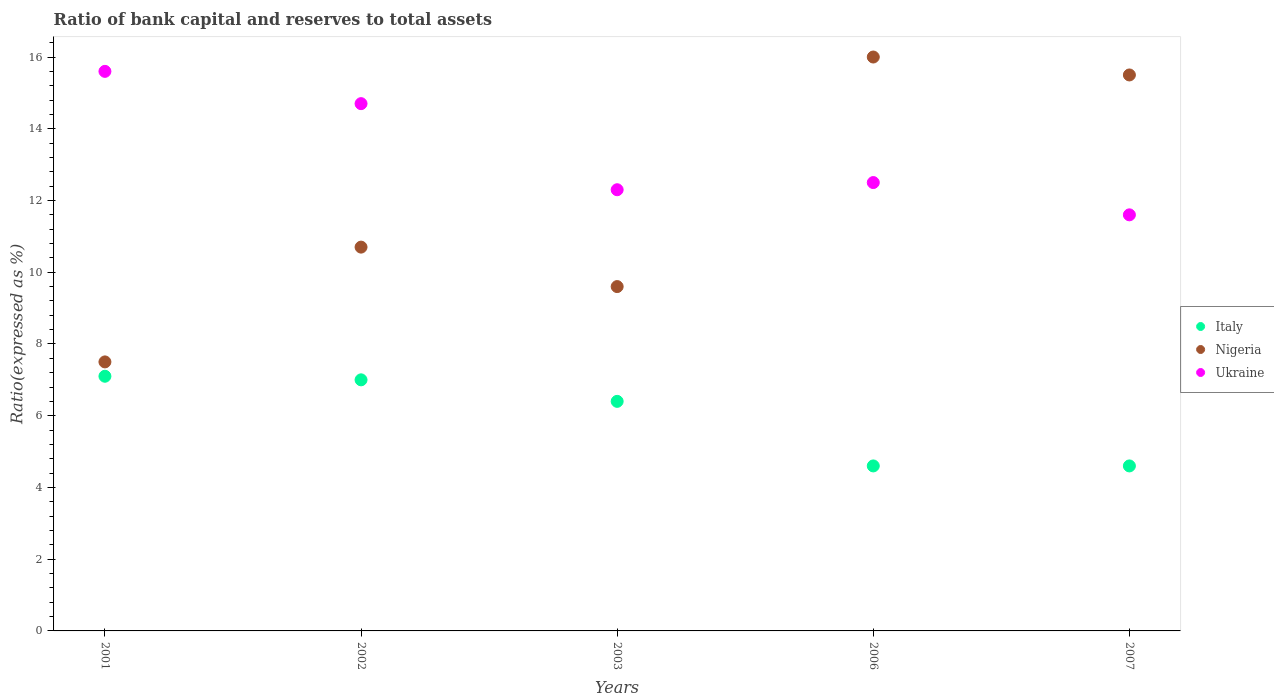How many different coloured dotlines are there?
Ensure brevity in your answer.  3. Across all years, what is the maximum ratio of bank capital and reserves to total assets in Italy?
Your response must be concise. 7.1. What is the total ratio of bank capital and reserves to total assets in Nigeria in the graph?
Your answer should be compact. 59.3. What is the difference between the ratio of bank capital and reserves to total assets in Ukraine in 2002 and that in 2007?
Make the answer very short. 3.1. What is the average ratio of bank capital and reserves to total assets in Italy per year?
Ensure brevity in your answer.  5.94. In how many years, is the ratio of bank capital and reserves to total assets in Nigeria greater than 11.2 %?
Ensure brevity in your answer.  2. What is the ratio of the ratio of bank capital and reserves to total assets in Italy in 2003 to that in 2006?
Ensure brevity in your answer.  1.39. Is the ratio of bank capital and reserves to total assets in Nigeria in 2003 less than that in 2007?
Offer a very short reply. Yes. Is the difference between the ratio of bank capital and reserves to total assets in Italy in 2001 and 2002 greater than the difference between the ratio of bank capital and reserves to total assets in Ukraine in 2001 and 2002?
Make the answer very short. No. What is the difference between the highest and the second highest ratio of bank capital and reserves to total assets in Italy?
Offer a terse response. 0.1. What is the difference between the highest and the lowest ratio of bank capital and reserves to total assets in Nigeria?
Your answer should be compact. 8.5. Is the sum of the ratio of bank capital and reserves to total assets in Italy in 2001 and 2002 greater than the maximum ratio of bank capital and reserves to total assets in Ukraine across all years?
Provide a succinct answer. No. Does the ratio of bank capital and reserves to total assets in Nigeria monotonically increase over the years?
Provide a short and direct response. No. Does the graph contain any zero values?
Your answer should be very brief. No. How are the legend labels stacked?
Your response must be concise. Vertical. What is the title of the graph?
Your response must be concise. Ratio of bank capital and reserves to total assets. Does "Puerto Rico" appear as one of the legend labels in the graph?
Keep it short and to the point. No. What is the label or title of the X-axis?
Offer a very short reply. Years. What is the label or title of the Y-axis?
Your answer should be very brief. Ratio(expressed as %). What is the Ratio(expressed as %) of Nigeria in 2001?
Your answer should be compact. 7.5. What is the Ratio(expressed as %) in Italy in 2002?
Offer a terse response. 7. What is the Ratio(expressed as %) of Nigeria in 2002?
Provide a succinct answer. 10.7. What is the Ratio(expressed as %) of Italy in 2006?
Make the answer very short. 4.6. What is the Ratio(expressed as %) in Ukraine in 2006?
Ensure brevity in your answer.  12.5. What is the Ratio(expressed as %) in Italy in 2007?
Offer a very short reply. 4.6. What is the Ratio(expressed as %) of Nigeria in 2007?
Your answer should be compact. 15.5. Across all years, what is the maximum Ratio(expressed as %) in Italy?
Your response must be concise. 7.1. What is the total Ratio(expressed as %) in Italy in the graph?
Keep it short and to the point. 29.7. What is the total Ratio(expressed as %) of Nigeria in the graph?
Keep it short and to the point. 59.3. What is the total Ratio(expressed as %) in Ukraine in the graph?
Offer a terse response. 66.7. What is the difference between the Ratio(expressed as %) in Italy in 2001 and that in 2002?
Offer a very short reply. 0.1. What is the difference between the Ratio(expressed as %) of Nigeria in 2001 and that in 2002?
Offer a terse response. -3.2. What is the difference between the Ratio(expressed as %) in Ukraine in 2001 and that in 2002?
Your answer should be very brief. 0.9. What is the difference between the Ratio(expressed as %) of Italy in 2001 and that in 2003?
Offer a very short reply. 0.7. What is the difference between the Ratio(expressed as %) of Nigeria in 2001 and that in 2003?
Keep it short and to the point. -2.1. What is the difference between the Ratio(expressed as %) in Ukraine in 2001 and that in 2006?
Offer a very short reply. 3.1. What is the difference between the Ratio(expressed as %) in Ukraine in 2001 and that in 2007?
Make the answer very short. 4. What is the difference between the Ratio(expressed as %) in Italy in 2002 and that in 2003?
Offer a very short reply. 0.6. What is the difference between the Ratio(expressed as %) of Ukraine in 2002 and that in 2003?
Offer a terse response. 2.4. What is the difference between the Ratio(expressed as %) in Nigeria in 2002 and that in 2006?
Make the answer very short. -5.3. What is the difference between the Ratio(expressed as %) in Ukraine in 2002 and that in 2006?
Keep it short and to the point. 2.2. What is the difference between the Ratio(expressed as %) of Ukraine in 2003 and that in 2006?
Provide a short and direct response. -0.2. What is the difference between the Ratio(expressed as %) in Nigeria in 2003 and that in 2007?
Provide a short and direct response. -5.9. What is the difference between the Ratio(expressed as %) of Ukraine in 2003 and that in 2007?
Ensure brevity in your answer.  0.7. What is the difference between the Ratio(expressed as %) in Italy in 2006 and that in 2007?
Keep it short and to the point. 0. What is the difference between the Ratio(expressed as %) in Nigeria in 2006 and that in 2007?
Your answer should be very brief. 0.5. What is the difference between the Ratio(expressed as %) in Ukraine in 2006 and that in 2007?
Ensure brevity in your answer.  0.9. What is the difference between the Ratio(expressed as %) in Italy in 2001 and the Ratio(expressed as %) in Nigeria in 2002?
Your answer should be very brief. -3.6. What is the difference between the Ratio(expressed as %) in Italy in 2001 and the Ratio(expressed as %) in Ukraine in 2002?
Offer a terse response. -7.6. What is the difference between the Ratio(expressed as %) of Nigeria in 2001 and the Ratio(expressed as %) of Ukraine in 2002?
Provide a short and direct response. -7.2. What is the difference between the Ratio(expressed as %) of Italy in 2001 and the Ratio(expressed as %) of Nigeria in 2006?
Offer a terse response. -8.9. What is the difference between the Ratio(expressed as %) in Italy in 2001 and the Ratio(expressed as %) in Ukraine in 2006?
Offer a terse response. -5.4. What is the difference between the Ratio(expressed as %) of Italy in 2001 and the Ratio(expressed as %) of Nigeria in 2007?
Provide a short and direct response. -8.4. What is the difference between the Ratio(expressed as %) of Nigeria in 2001 and the Ratio(expressed as %) of Ukraine in 2007?
Offer a terse response. -4.1. What is the difference between the Ratio(expressed as %) in Nigeria in 2002 and the Ratio(expressed as %) in Ukraine in 2003?
Your answer should be compact. -1.6. What is the difference between the Ratio(expressed as %) in Italy in 2002 and the Ratio(expressed as %) in Nigeria in 2006?
Offer a terse response. -9. What is the difference between the Ratio(expressed as %) of Italy in 2002 and the Ratio(expressed as %) of Ukraine in 2006?
Your response must be concise. -5.5. What is the difference between the Ratio(expressed as %) of Nigeria in 2002 and the Ratio(expressed as %) of Ukraine in 2006?
Your response must be concise. -1.8. What is the difference between the Ratio(expressed as %) in Italy in 2002 and the Ratio(expressed as %) in Ukraine in 2007?
Offer a very short reply. -4.6. What is the difference between the Ratio(expressed as %) of Nigeria in 2002 and the Ratio(expressed as %) of Ukraine in 2007?
Your answer should be very brief. -0.9. What is the difference between the Ratio(expressed as %) of Nigeria in 2003 and the Ratio(expressed as %) of Ukraine in 2006?
Make the answer very short. -2.9. What is the difference between the Ratio(expressed as %) of Italy in 2003 and the Ratio(expressed as %) of Ukraine in 2007?
Make the answer very short. -5.2. What is the difference between the Ratio(expressed as %) of Nigeria in 2003 and the Ratio(expressed as %) of Ukraine in 2007?
Your answer should be very brief. -2. What is the difference between the Ratio(expressed as %) in Nigeria in 2006 and the Ratio(expressed as %) in Ukraine in 2007?
Your answer should be compact. 4.4. What is the average Ratio(expressed as %) of Italy per year?
Your response must be concise. 5.94. What is the average Ratio(expressed as %) of Nigeria per year?
Ensure brevity in your answer.  11.86. What is the average Ratio(expressed as %) in Ukraine per year?
Keep it short and to the point. 13.34. In the year 2001, what is the difference between the Ratio(expressed as %) in Italy and Ratio(expressed as %) in Ukraine?
Provide a succinct answer. -8.5. In the year 2001, what is the difference between the Ratio(expressed as %) of Nigeria and Ratio(expressed as %) of Ukraine?
Your response must be concise. -8.1. In the year 2002, what is the difference between the Ratio(expressed as %) of Italy and Ratio(expressed as %) of Ukraine?
Your response must be concise. -7.7. In the year 2002, what is the difference between the Ratio(expressed as %) in Nigeria and Ratio(expressed as %) in Ukraine?
Keep it short and to the point. -4. In the year 2003, what is the difference between the Ratio(expressed as %) in Italy and Ratio(expressed as %) in Ukraine?
Your response must be concise. -5.9. In the year 2006, what is the difference between the Ratio(expressed as %) in Italy and Ratio(expressed as %) in Nigeria?
Ensure brevity in your answer.  -11.4. In the year 2007, what is the difference between the Ratio(expressed as %) in Italy and Ratio(expressed as %) in Nigeria?
Give a very brief answer. -10.9. In the year 2007, what is the difference between the Ratio(expressed as %) in Nigeria and Ratio(expressed as %) in Ukraine?
Keep it short and to the point. 3.9. What is the ratio of the Ratio(expressed as %) in Italy in 2001 to that in 2002?
Your response must be concise. 1.01. What is the ratio of the Ratio(expressed as %) of Nigeria in 2001 to that in 2002?
Keep it short and to the point. 0.7. What is the ratio of the Ratio(expressed as %) in Ukraine in 2001 to that in 2002?
Offer a very short reply. 1.06. What is the ratio of the Ratio(expressed as %) in Italy in 2001 to that in 2003?
Offer a terse response. 1.11. What is the ratio of the Ratio(expressed as %) of Nigeria in 2001 to that in 2003?
Give a very brief answer. 0.78. What is the ratio of the Ratio(expressed as %) of Ukraine in 2001 to that in 2003?
Offer a very short reply. 1.27. What is the ratio of the Ratio(expressed as %) in Italy in 2001 to that in 2006?
Keep it short and to the point. 1.54. What is the ratio of the Ratio(expressed as %) of Nigeria in 2001 to that in 2006?
Provide a short and direct response. 0.47. What is the ratio of the Ratio(expressed as %) of Ukraine in 2001 to that in 2006?
Give a very brief answer. 1.25. What is the ratio of the Ratio(expressed as %) of Italy in 2001 to that in 2007?
Ensure brevity in your answer.  1.54. What is the ratio of the Ratio(expressed as %) of Nigeria in 2001 to that in 2007?
Provide a succinct answer. 0.48. What is the ratio of the Ratio(expressed as %) of Ukraine in 2001 to that in 2007?
Make the answer very short. 1.34. What is the ratio of the Ratio(expressed as %) of Italy in 2002 to that in 2003?
Your answer should be very brief. 1.09. What is the ratio of the Ratio(expressed as %) of Nigeria in 2002 to that in 2003?
Provide a succinct answer. 1.11. What is the ratio of the Ratio(expressed as %) of Ukraine in 2002 to that in 2003?
Make the answer very short. 1.2. What is the ratio of the Ratio(expressed as %) of Italy in 2002 to that in 2006?
Your answer should be very brief. 1.52. What is the ratio of the Ratio(expressed as %) in Nigeria in 2002 to that in 2006?
Offer a very short reply. 0.67. What is the ratio of the Ratio(expressed as %) in Ukraine in 2002 to that in 2006?
Ensure brevity in your answer.  1.18. What is the ratio of the Ratio(expressed as %) in Italy in 2002 to that in 2007?
Offer a terse response. 1.52. What is the ratio of the Ratio(expressed as %) of Nigeria in 2002 to that in 2007?
Your answer should be very brief. 0.69. What is the ratio of the Ratio(expressed as %) of Ukraine in 2002 to that in 2007?
Ensure brevity in your answer.  1.27. What is the ratio of the Ratio(expressed as %) in Italy in 2003 to that in 2006?
Your response must be concise. 1.39. What is the ratio of the Ratio(expressed as %) in Nigeria in 2003 to that in 2006?
Your answer should be very brief. 0.6. What is the ratio of the Ratio(expressed as %) in Italy in 2003 to that in 2007?
Your answer should be compact. 1.39. What is the ratio of the Ratio(expressed as %) of Nigeria in 2003 to that in 2007?
Your answer should be very brief. 0.62. What is the ratio of the Ratio(expressed as %) of Ukraine in 2003 to that in 2007?
Make the answer very short. 1.06. What is the ratio of the Ratio(expressed as %) in Nigeria in 2006 to that in 2007?
Offer a very short reply. 1.03. What is the ratio of the Ratio(expressed as %) of Ukraine in 2006 to that in 2007?
Your answer should be very brief. 1.08. What is the difference between the highest and the second highest Ratio(expressed as %) of Italy?
Make the answer very short. 0.1. What is the difference between the highest and the second highest Ratio(expressed as %) in Nigeria?
Make the answer very short. 0.5. What is the difference between the highest and the second highest Ratio(expressed as %) in Ukraine?
Your response must be concise. 0.9. What is the difference between the highest and the lowest Ratio(expressed as %) in Nigeria?
Ensure brevity in your answer.  8.5. 